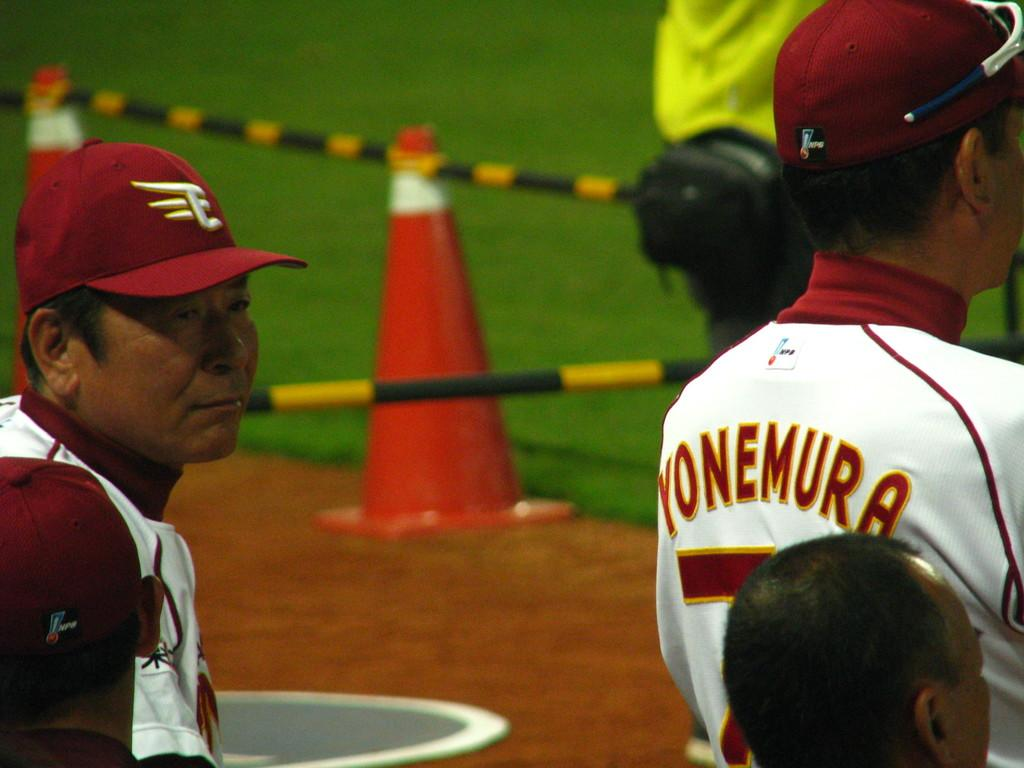Provide a one-sentence caption for the provided image. A man wearing a red hat stands behind a man wearing a Yonemura jersey. 